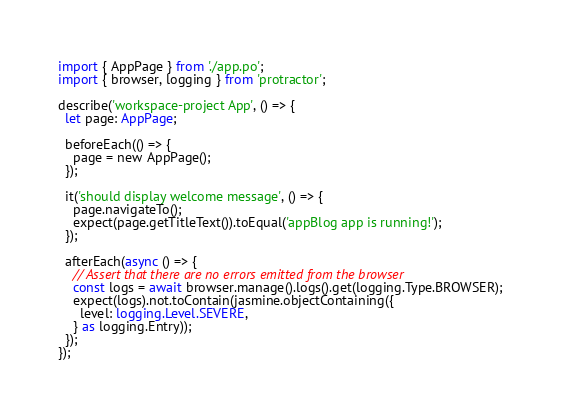Convert code to text. <code><loc_0><loc_0><loc_500><loc_500><_TypeScript_>import { AppPage } from './app.po';
import { browser, logging } from 'protractor';

describe('workspace-project App', () => {
  let page: AppPage;

  beforeEach(() => {
    page = new AppPage();
  });

  it('should display welcome message', () => {
    page.navigateTo();
    expect(page.getTitleText()).toEqual('appBlog app is running!');
  });

  afterEach(async () => {
    // Assert that there are no errors emitted from the browser
    const logs = await browser.manage().logs().get(logging.Type.BROWSER);
    expect(logs).not.toContain(jasmine.objectContaining({
      level: logging.Level.SEVERE,
    } as logging.Entry));
  });
});
</code> 